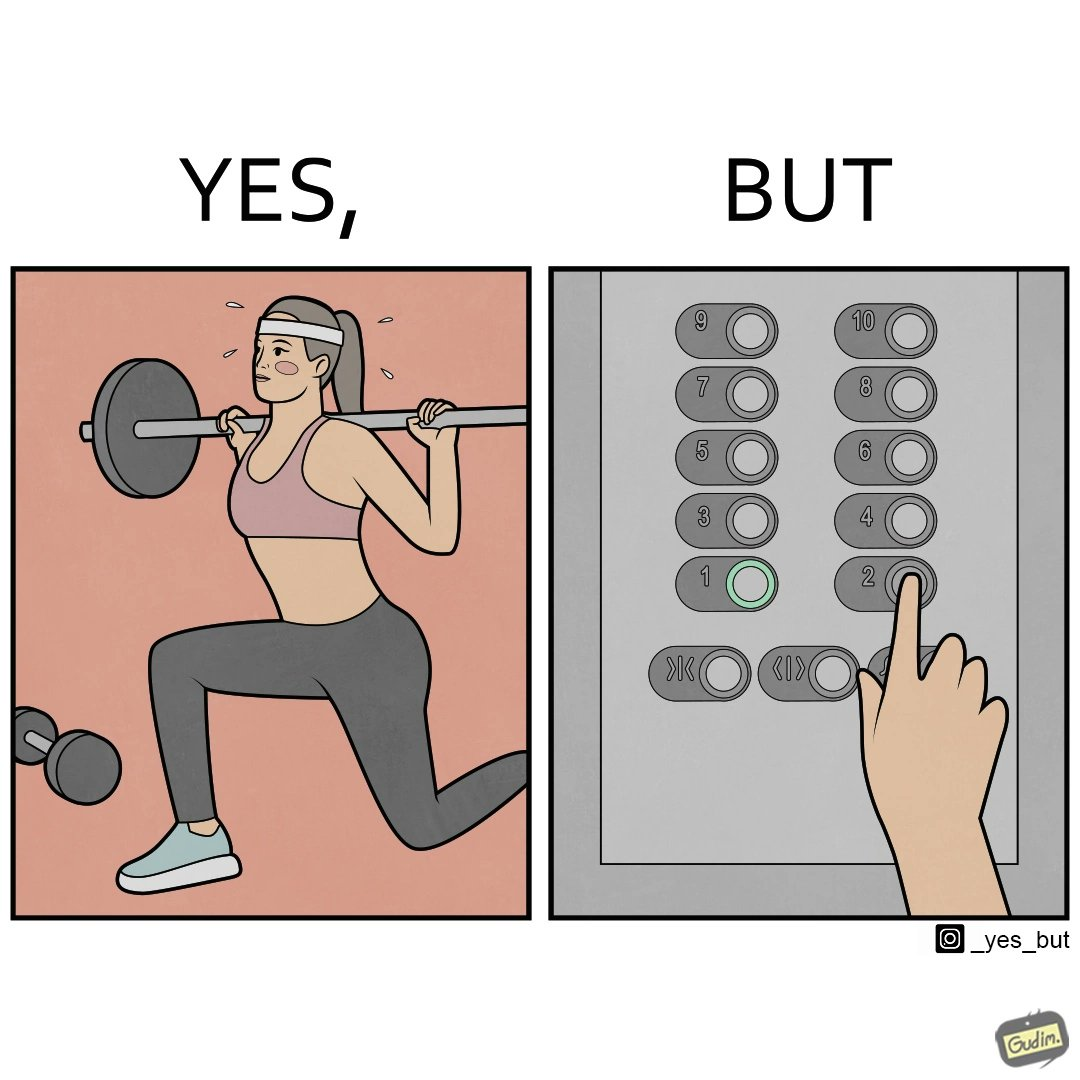What is shown in this image? The image is satirical because it shows that while people do various kinds of exercises and go to gym to stay fit, they avoid doing simplest of physical tasks like using stairs instead of elevators to get to even the first or the second floor of a building. 